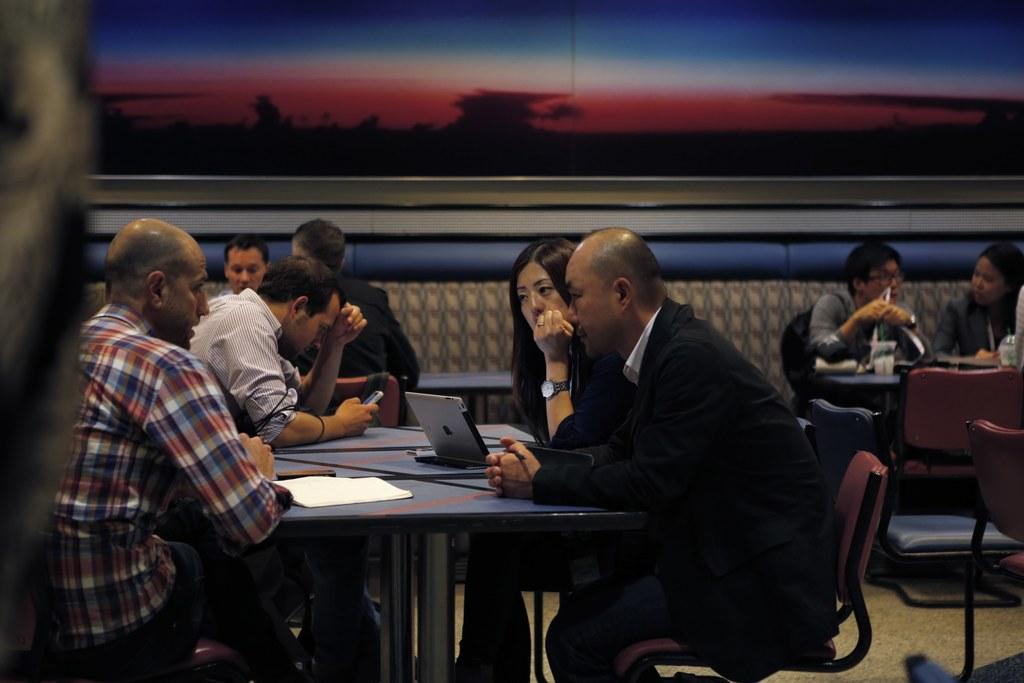What is the main activity taking place in the image? There is a group of people sitting at a table. Can you describe the interaction between the woman and the man? A woman is staring at a man in the image. What electronic device is present on the table? There is a laptop on the table. What else can be seen on the table besides the laptop? There are papers on the table. What type of fuel is being used by the man in the image? There is no indication of any fuel being used in the image; it features a group of people sitting at a table. How many teeth can be seen in the mouth of the woman staring at the man? There is no information about the woman's teeth or mouth in the image, as it focuses on the interaction between the woman and the man. 